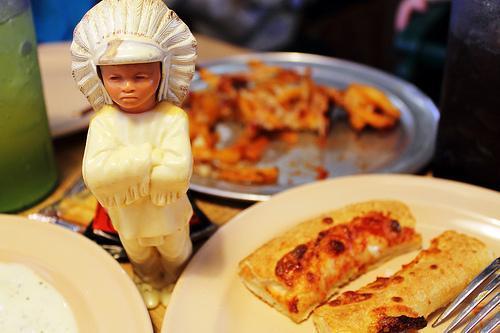How many plates are there?
Give a very brief answer. 2. 